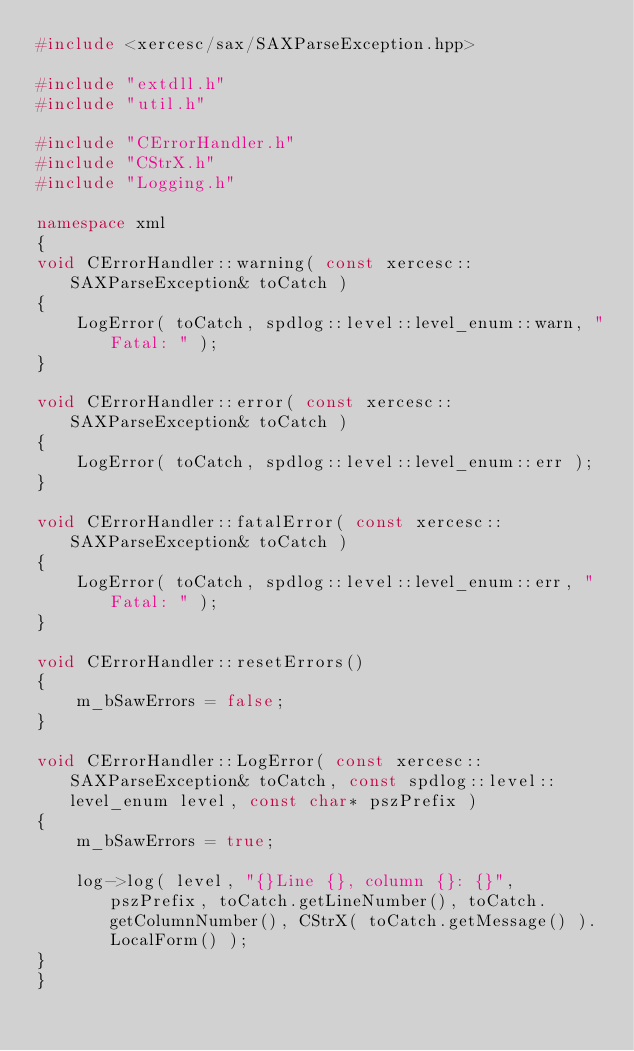Convert code to text. <code><loc_0><loc_0><loc_500><loc_500><_C++_>#include <xercesc/sax/SAXParseException.hpp>

#include "extdll.h"
#include "util.h"

#include "CErrorHandler.h"
#include "CStrX.h"
#include "Logging.h"

namespace xml
{
void CErrorHandler::warning( const xercesc::SAXParseException& toCatch )
{
	LogError( toCatch, spdlog::level::level_enum::warn, "Fatal: " );
}

void CErrorHandler::error( const xercesc::SAXParseException& toCatch )
{
	LogError( toCatch, spdlog::level::level_enum::err );
}

void CErrorHandler::fatalError( const xercesc::SAXParseException& toCatch )
{
	LogError( toCatch, spdlog::level::level_enum::err, "Fatal: " );
}

void CErrorHandler::resetErrors()
{
	m_bSawErrors = false;
}

void CErrorHandler::LogError( const xercesc::SAXParseException& toCatch, const spdlog::level::level_enum level, const char* pszPrefix )
{
	m_bSawErrors = true;

	log->log( level, "{}Line {}, column {}: {}", pszPrefix, toCatch.getLineNumber(), toCatch.getColumnNumber(), CStrX( toCatch.getMessage() ).LocalForm() );
}
}
</code> 